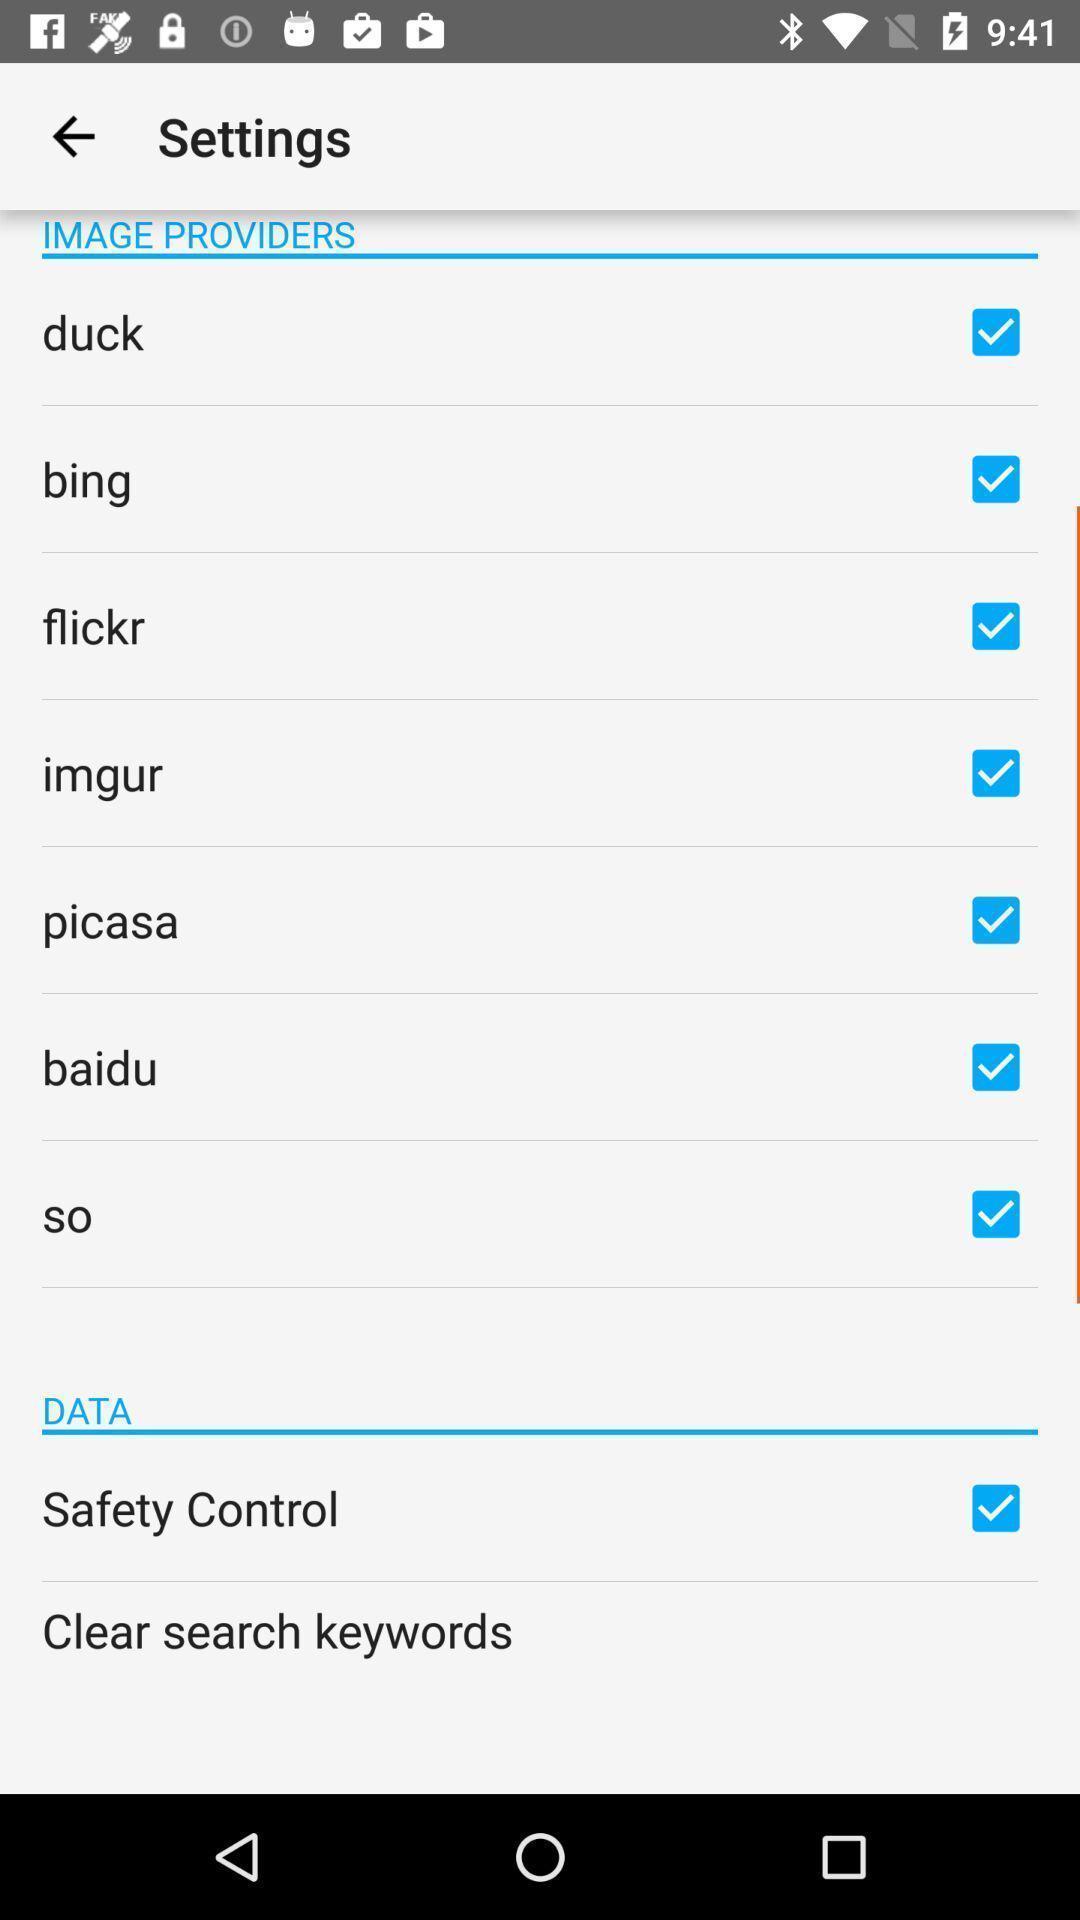Explain the elements present in this screenshot. Settings page in a photo management app. 